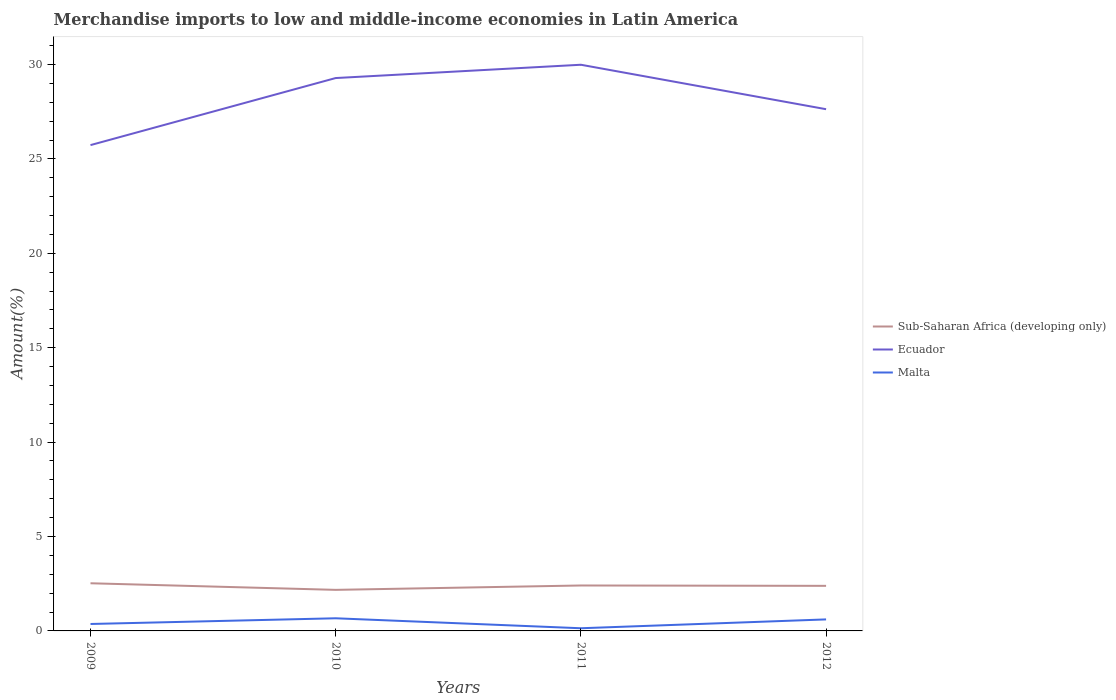Is the number of lines equal to the number of legend labels?
Give a very brief answer. Yes. Across all years, what is the maximum percentage of amount earned from merchandise imports in Sub-Saharan Africa (developing only)?
Provide a succinct answer. 2.17. In which year was the percentage of amount earned from merchandise imports in Ecuador maximum?
Your answer should be compact. 2009. What is the total percentage of amount earned from merchandise imports in Sub-Saharan Africa (developing only) in the graph?
Make the answer very short. 0.35. What is the difference between the highest and the second highest percentage of amount earned from merchandise imports in Ecuador?
Offer a terse response. 4.26. Is the percentage of amount earned from merchandise imports in Malta strictly greater than the percentage of amount earned from merchandise imports in Sub-Saharan Africa (developing only) over the years?
Your response must be concise. Yes. How many lines are there?
Your response must be concise. 3. How many years are there in the graph?
Ensure brevity in your answer.  4. Does the graph contain any zero values?
Ensure brevity in your answer.  No. What is the title of the graph?
Ensure brevity in your answer.  Merchandise imports to low and middle-income economies in Latin America. What is the label or title of the Y-axis?
Offer a terse response. Amount(%). What is the Amount(%) of Sub-Saharan Africa (developing only) in 2009?
Your response must be concise. 2.52. What is the Amount(%) in Ecuador in 2009?
Offer a terse response. 25.73. What is the Amount(%) of Malta in 2009?
Give a very brief answer. 0.37. What is the Amount(%) in Sub-Saharan Africa (developing only) in 2010?
Keep it short and to the point. 2.17. What is the Amount(%) of Ecuador in 2010?
Provide a succinct answer. 29.28. What is the Amount(%) in Malta in 2010?
Provide a succinct answer. 0.67. What is the Amount(%) in Sub-Saharan Africa (developing only) in 2011?
Your answer should be compact. 2.41. What is the Amount(%) of Ecuador in 2011?
Your answer should be compact. 29.99. What is the Amount(%) in Malta in 2011?
Your answer should be very brief. 0.14. What is the Amount(%) of Sub-Saharan Africa (developing only) in 2012?
Ensure brevity in your answer.  2.39. What is the Amount(%) in Ecuador in 2012?
Make the answer very short. 27.63. What is the Amount(%) of Malta in 2012?
Make the answer very short. 0.61. Across all years, what is the maximum Amount(%) in Sub-Saharan Africa (developing only)?
Make the answer very short. 2.52. Across all years, what is the maximum Amount(%) of Ecuador?
Offer a terse response. 29.99. Across all years, what is the maximum Amount(%) in Malta?
Provide a short and direct response. 0.67. Across all years, what is the minimum Amount(%) in Sub-Saharan Africa (developing only)?
Keep it short and to the point. 2.17. Across all years, what is the minimum Amount(%) in Ecuador?
Your response must be concise. 25.73. Across all years, what is the minimum Amount(%) of Malta?
Keep it short and to the point. 0.14. What is the total Amount(%) in Sub-Saharan Africa (developing only) in the graph?
Ensure brevity in your answer.  9.49. What is the total Amount(%) in Ecuador in the graph?
Give a very brief answer. 112.63. What is the total Amount(%) in Malta in the graph?
Keep it short and to the point. 1.79. What is the difference between the Amount(%) of Sub-Saharan Africa (developing only) in 2009 and that in 2010?
Your answer should be very brief. 0.35. What is the difference between the Amount(%) in Ecuador in 2009 and that in 2010?
Give a very brief answer. -3.55. What is the difference between the Amount(%) of Malta in 2009 and that in 2010?
Your answer should be very brief. -0.3. What is the difference between the Amount(%) in Sub-Saharan Africa (developing only) in 2009 and that in 2011?
Provide a short and direct response. 0.12. What is the difference between the Amount(%) in Ecuador in 2009 and that in 2011?
Offer a very short reply. -4.26. What is the difference between the Amount(%) of Malta in 2009 and that in 2011?
Provide a short and direct response. 0.23. What is the difference between the Amount(%) of Sub-Saharan Africa (developing only) in 2009 and that in 2012?
Provide a short and direct response. 0.14. What is the difference between the Amount(%) of Ecuador in 2009 and that in 2012?
Offer a terse response. -1.9. What is the difference between the Amount(%) in Malta in 2009 and that in 2012?
Your answer should be compact. -0.24. What is the difference between the Amount(%) in Sub-Saharan Africa (developing only) in 2010 and that in 2011?
Your answer should be very brief. -0.23. What is the difference between the Amount(%) in Ecuador in 2010 and that in 2011?
Offer a very short reply. -0.7. What is the difference between the Amount(%) of Malta in 2010 and that in 2011?
Keep it short and to the point. 0.53. What is the difference between the Amount(%) of Sub-Saharan Africa (developing only) in 2010 and that in 2012?
Offer a very short reply. -0.21. What is the difference between the Amount(%) of Ecuador in 2010 and that in 2012?
Your answer should be very brief. 1.65. What is the difference between the Amount(%) of Malta in 2010 and that in 2012?
Ensure brevity in your answer.  0.06. What is the difference between the Amount(%) of Sub-Saharan Africa (developing only) in 2011 and that in 2012?
Offer a very short reply. 0.02. What is the difference between the Amount(%) of Ecuador in 2011 and that in 2012?
Provide a succinct answer. 2.35. What is the difference between the Amount(%) of Malta in 2011 and that in 2012?
Your answer should be compact. -0.47. What is the difference between the Amount(%) in Sub-Saharan Africa (developing only) in 2009 and the Amount(%) in Ecuador in 2010?
Your answer should be compact. -26.76. What is the difference between the Amount(%) in Sub-Saharan Africa (developing only) in 2009 and the Amount(%) in Malta in 2010?
Provide a succinct answer. 1.85. What is the difference between the Amount(%) in Ecuador in 2009 and the Amount(%) in Malta in 2010?
Provide a succinct answer. 25.06. What is the difference between the Amount(%) of Sub-Saharan Africa (developing only) in 2009 and the Amount(%) of Ecuador in 2011?
Make the answer very short. -27.46. What is the difference between the Amount(%) in Sub-Saharan Africa (developing only) in 2009 and the Amount(%) in Malta in 2011?
Your answer should be compact. 2.38. What is the difference between the Amount(%) in Ecuador in 2009 and the Amount(%) in Malta in 2011?
Keep it short and to the point. 25.59. What is the difference between the Amount(%) of Sub-Saharan Africa (developing only) in 2009 and the Amount(%) of Ecuador in 2012?
Provide a succinct answer. -25.11. What is the difference between the Amount(%) of Sub-Saharan Africa (developing only) in 2009 and the Amount(%) of Malta in 2012?
Your answer should be compact. 1.91. What is the difference between the Amount(%) of Ecuador in 2009 and the Amount(%) of Malta in 2012?
Ensure brevity in your answer.  25.12. What is the difference between the Amount(%) in Sub-Saharan Africa (developing only) in 2010 and the Amount(%) in Ecuador in 2011?
Your answer should be compact. -27.81. What is the difference between the Amount(%) of Sub-Saharan Africa (developing only) in 2010 and the Amount(%) of Malta in 2011?
Offer a very short reply. 2.03. What is the difference between the Amount(%) in Ecuador in 2010 and the Amount(%) in Malta in 2011?
Your response must be concise. 29.14. What is the difference between the Amount(%) in Sub-Saharan Africa (developing only) in 2010 and the Amount(%) in Ecuador in 2012?
Ensure brevity in your answer.  -25.46. What is the difference between the Amount(%) in Sub-Saharan Africa (developing only) in 2010 and the Amount(%) in Malta in 2012?
Provide a short and direct response. 1.56. What is the difference between the Amount(%) of Ecuador in 2010 and the Amount(%) of Malta in 2012?
Give a very brief answer. 28.67. What is the difference between the Amount(%) of Sub-Saharan Africa (developing only) in 2011 and the Amount(%) of Ecuador in 2012?
Make the answer very short. -25.23. What is the difference between the Amount(%) in Sub-Saharan Africa (developing only) in 2011 and the Amount(%) in Malta in 2012?
Your response must be concise. 1.8. What is the difference between the Amount(%) of Ecuador in 2011 and the Amount(%) of Malta in 2012?
Make the answer very short. 29.38. What is the average Amount(%) in Sub-Saharan Africa (developing only) per year?
Your response must be concise. 2.37. What is the average Amount(%) of Ecuador per year?
Provide a short and direct response. 28.16. What is the average Amount(%) of Malta per year?
Your answer should be very brief. 0.45. In the year 2009, what is the difference between the Amount(%) in Sub-Saharan Africa (developing only) and Amount(%) in Ecuador?
Make the answer very short. -23.21. In the year 2009, what is the difference between the Amount(%) in Sub-Saharan Africa (developing only) and Amount(%) in Malta?
Ensure brevity in your answer.  2.16. In the year 2009, what is the difference between the Amount(%) in Ecuador and Amount(%) in Malta?
Offer a terse response. 25.36. In the year 2010, what is the difference between the Amount(%) of Sub-Saharan Africa (developing only) and Amount(%) of Ecuador?
Ensure brevity in your answer.  -27.11. In the year 2010, what is the difference between the Amount(%) of Sub-Saharan Africa (developing only) and Amount(%) of Malta?
Your answer should be very brief. 1.51. In the year 2010, what is the difference between the Amount(%) in Ecuador and Amount(%) in Malta?
Keep it short and to the point. 28.61. In the year 2011, what is the difference between the Amount(%) of Sub-Saharan Africa (developing only) and Amount(%) of Ecuador?
Provide a short and direct response. -27.58. In the year 2011, what is the difference between the Amount(%) of Sub-Saharan Africa (developing only) and Amount(%) of Malta?
Provide a succinct answer. 2.27. In the year 2011, what is the difference between the Amount(%) in Ecuador and Amount(%) in Malta?
Keep it short and to the point. 29.84. In the year 2012, what is the difference between the Amount(%) in Sub-Saharan Africa (developing only) and Amount(%) in Ecuador?
Give a very brief answer. -25.24. In the year 2012, what is the difference between the Amount(%) in Sub-Saharan Africa (developing only) and Amount(%) in Malta?
Your answer should be compact. 1.78. In the year 2012, what is the difference between the Amount(%) of Ecuador and Amount(%) of Malta?
Your response must be concise. 27.02. What is the ratio of the Amount(%) of Sub-Saharan Africa (developing only) in 2009 to that in 2010?
Your answer should be very brief. 1.16. What is the ratio of the Amount(%) of Ecuador in 2009 to that in 2010?
Provide a succinct answer. 0.88. What is the ratio of the Amount(%) of Malta in 2009 to that in 2010?
Offer a terse response. 0.55. What is the ratio of the Amount(%) of Sub-Saharan Africa (developing only) in 2009 to that in 2011?
Provide a short and direct response. 1.05. What is the ratio of the Amount(%) of Ecuador in 2009 to that in 2011?
Provide a short and direct response. 0.86. What is the ratio of the Amount(%) in Malta in 2009 to that in 2011?
Give a very brief answer. 2.6. What is the ratio of the Amount(%) in Sub-Saharan Africa (developing only) in 2009 to that in 2012?
Your response must be concise. 1.06. What is the ratio of the Amount(%) in Ecuador in 2009 to that in 2012?
Offer a terse response. 0.93. What is the ratio of the Amount(%) in Malta in 2009 to that in 2012?
Provide a short and direct response. 0.6. What is the ratio of the Amount(%) in Sub-Saharan Africa (developing only) in 2010 to that in 2011?
Your answer should be very brief. 0.9. What is the ratio of the Amount(%) of Ecuador in 2010 to that in 2011?
Make the answer very short. 0.98. What is the ratio of the Amount(%) in Malta in 2010 to that in 2011?
Your answer should be very brief. 4.74. What is the ratio of the Amount(%) of Sub-Saharan Africa (developing only) in 2010 to that in 2012?
Provide a succinct answer. 0.91. What is the ratio of the Amount(%) in Ecuador in 2010 to that in 2012?
Your answer should be compact. 1.06. What is the ratio of the Amount(%) of Malta in 2010 to that in 2012?
Offer a very short reply. 1.1. What is the ratio of the Amount(%) of Ecuador in 2011 to that in 2012?
Provide a succinct answer. 1.09. What is the ratio of the Amount(%) of Malta in 2011 to that in 2012?
Provide a short and direct response. 0.23. What is the difference between the highest and the second highest Amount(%) in Sub-Saharan Africa (developing only)?
Provide a short and direct response. 0.12. What is the difference between the highest and the second highest Amount(%) in Ecuador?
Keep it short and to the point. 0.7. What is the difference between the highest and the second highest Amount(%) of Malta?
Your answer should be very brief. 0.06. What is the difference between the highest and the lowest Amount(%) in Sub-Saharan Africa (developing only)?
Ensure brevity in your answer.  0.35. What is the difference between the highest and the lowest Amount(%) in Ecuador?
Your answer should be very brief. 4.26. What is the difference between the highest and the lowest Amount(%) in Malta?
Your response must be concise. 0.53. 